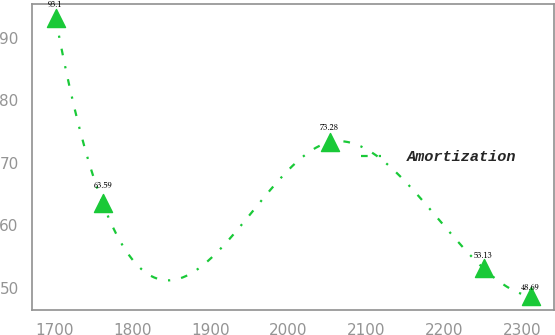Convert chart. <chart><loc_0><loc_0><loc_500><loc_500><line_chart><ecel><fcel>Amortization<nl><fcel>1701.96<fcel>93.1<nl><fcel>1762.12<fcel>63.59<nl><fcel>2052.79<fcel>73.28<nl><fcel>2250.04<fcel>53.13<nl><fcel>2310.2<fcel>48.69<nl></chart> 